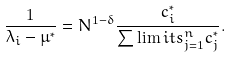Convert formula to latex. <formula><loc_0><loc_0><loc_500><loc_500>\frac { 1 } { \lambda _ { i } - \mu ^ { * } } = N ^ { 1 - \delta } \frac { c _ { i } ^ { * } } { \sum \lim i t s _ { j = 1 } ^ { n } c _ { j } ^ { * } } .</formula> 